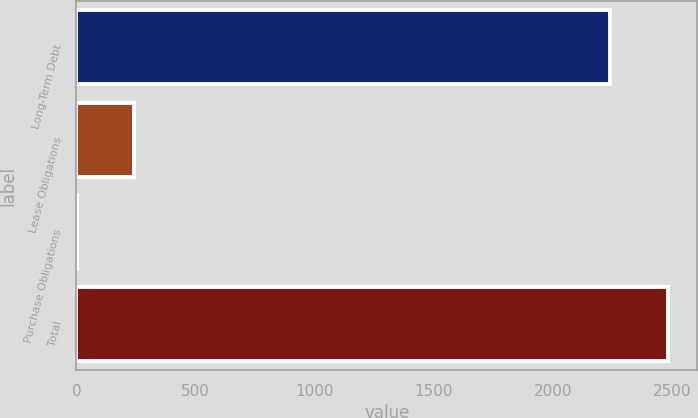Convert chart. <chart><loc_0><loc_0><loc_500><loc_500><bar_chart><fcel>Long-Term Debt<fcel>Lease Obligations<fcel>Purchase Obligations<fcel>Total<nl><fcel>2242.6<fcel>242.03<fcel>0.7<fcel>2483.93<nl></chart> 